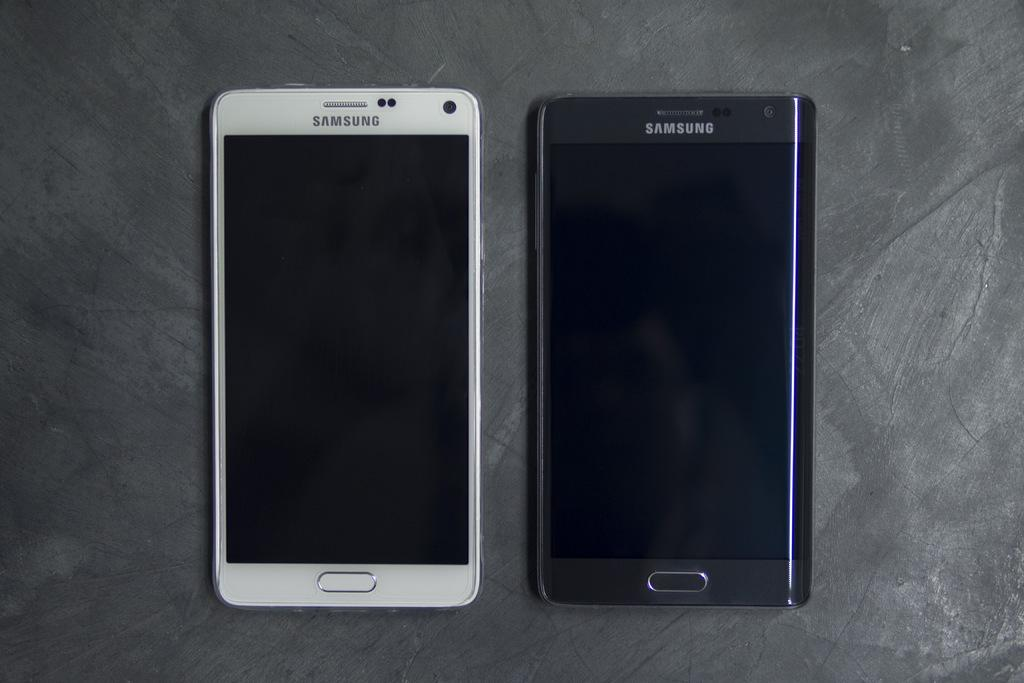Provide a one-sentence caption for the provided image. Saumsung smart phones are available in more than one color. 